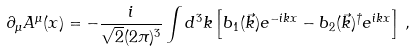Convert formula to latex. <formula><loc_0><loc_0><loc_500><loc_500>\partial _ { \mu } A ^ { \mu } ( x ) = - \frac { i } { \sqrt { 2 } ( 2 \pi ) ^ { 3 } } \int d ^ { 3 } k \left [ b _ { 1 } ( \vec { k } ) e ^ { - i k x } - b _ { 2 } ( \vec { k } ) ^ { \dagger } e ^ { i k x } \right ] \, ,</formula> 